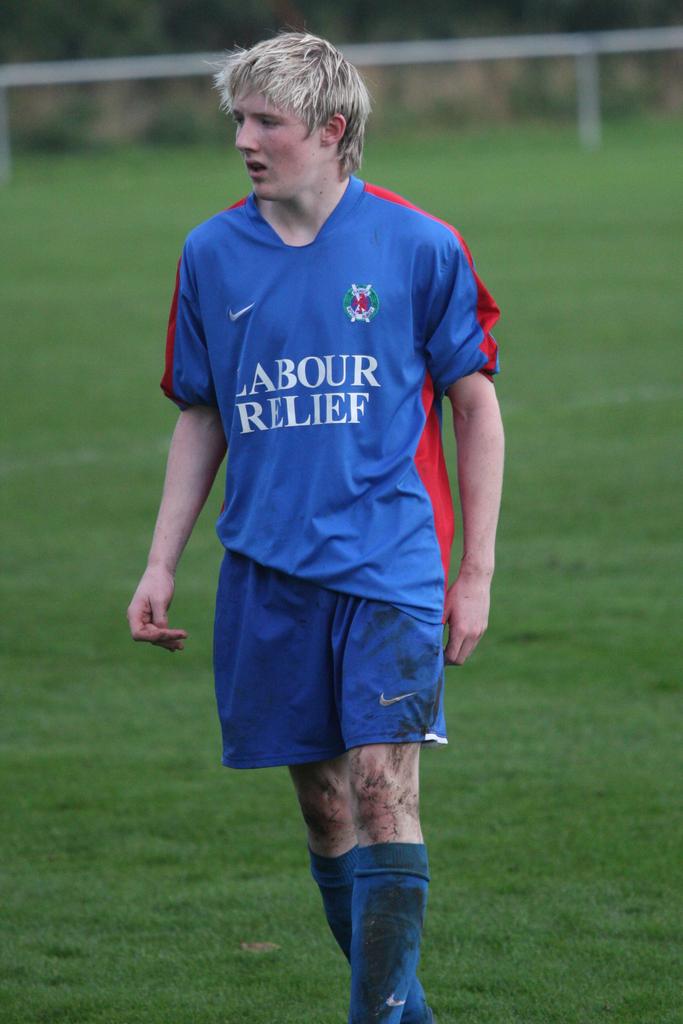Are they part of labour relief?
Keep it short and to the point. Yes. What team does the man play for?
Your answer should be compact. Labour relief. 